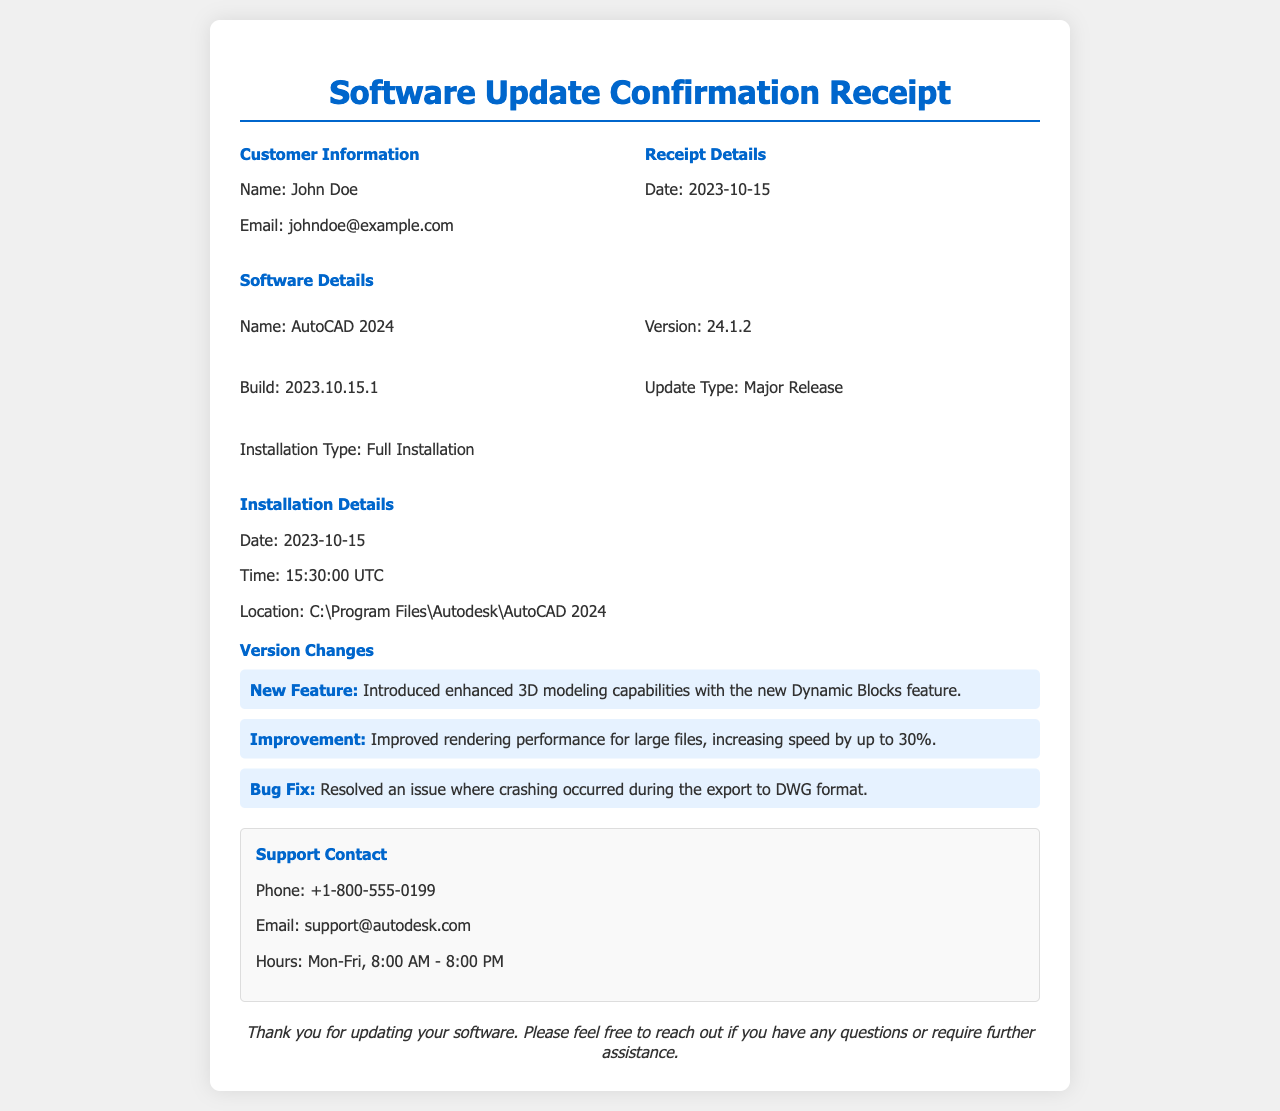What is the customer name? The customer name is listed under "Customer Information" in the document.
Answer: John Doe What is the email address? The email address is provided in the "Customer Information" section.
Answer: johndoe@example.com When was the software updated? The update date is mentioned under "Receipt Details."
Answer: 2023-10-15 What is the software version? The software version is specified in the "Software Details" section.
Answer: 24.1.2 What is the installation location? The installation location can be found in the "Installation Details" section.
Answer: C:\Program Files\Autodesk\AutoCAD 2024 What type of update is this? The update type is mentioned in the "Software Details" section.
Answer: Major Release What is the new feature introduced? The new feature is listed under "Version Changes."
Answer: Enhanced 3D modeling capabilities with the new Dynamic Blocks feature How much has rendering performance improved by? The improvement percentage is stated under "Version Changes."
Answer: Up to 30% What is the support phone number? The support phone number is indicated in the "Support Contact" section.
Answer: +1-800-555-0199 During what hours is support available? The support hours are provided in the "Support Contact" section.
Answer: Mon-Fri, 8:00 AM - 8:00 PM 